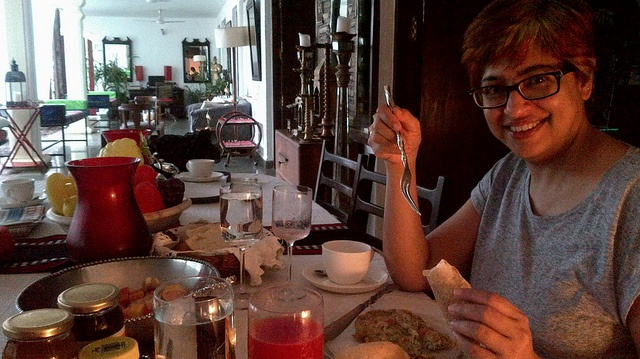Describe the objects in this image and their specific colors. I can see people in white, maroon, black, gray, and brown tones, vase in white, maroon, black, and gray tones, cup in white, gray, maroon, brown, and black tones, wine glass in white, gray, and maroon tones, and wine glass in white, gray, maroon, and black tones in this image. 